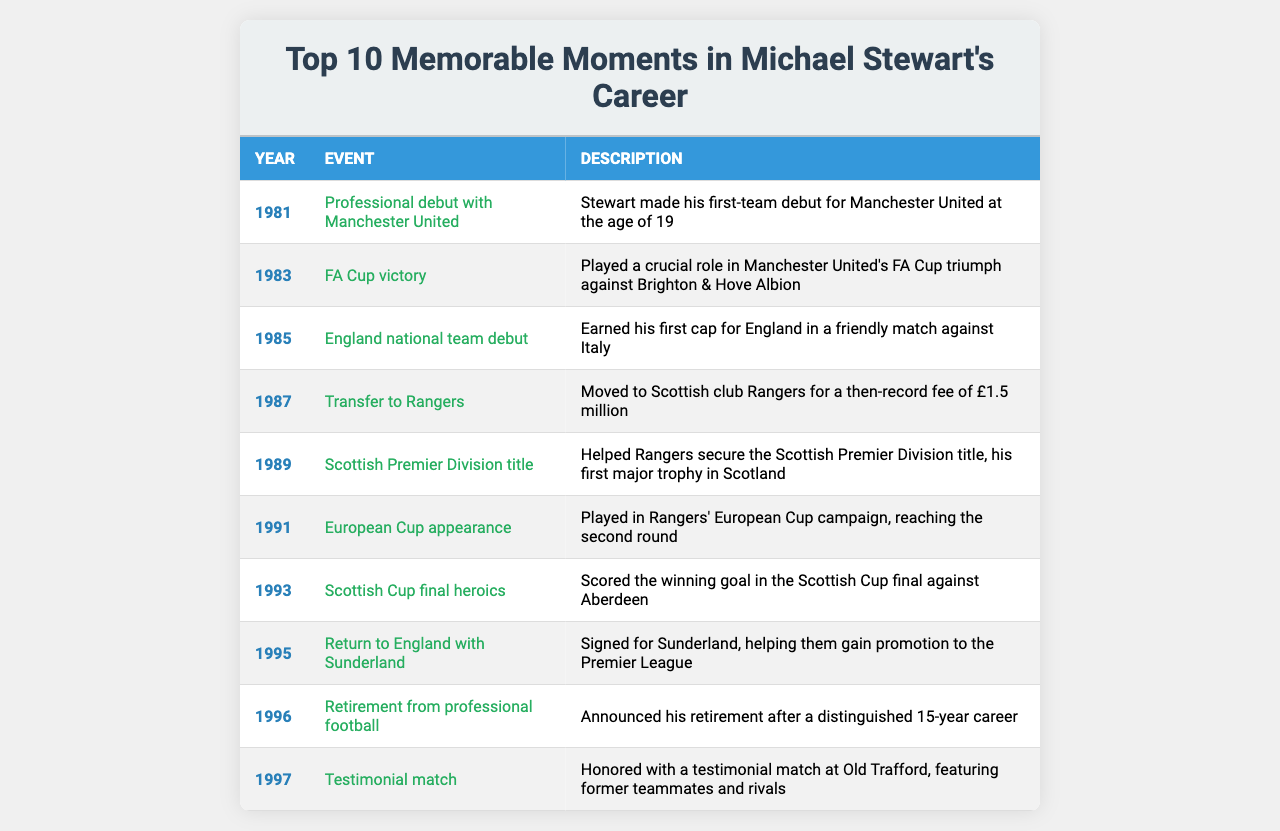What year did Michael Stewart make his professional debut? The table lists the memorable moments in Michael Stewart's career, and the first entry shows that he made his professional debut in the year 1981.
Answer: 1981 Which event marked Michael Stewart's first major trophy in Scotland? The table indicates that he helped Rangers secure the Scottish Premier Division title in 1989, which is noted as his first major trophy in Scotland.
Answer: Scottish Premier Division title Did Michael Stewart earn caps with the England national team? The table confirms that he made his England national team debut in 1985, which implies he earned caps.
Answer: Yes How many years was Michael Stewart's professional career? The table states that he retired in 1996 after a professional career beginning in 1981, which gives us 1996 - 1981 = 15 years.
Answer: 15 years What significant achievement occurred in the same year as Michael Stewart's transfer to Rangers? In 1987, the table notes Stewart's transfer to Rangers for a record fee, marking a significant achievement that year.
Answer: Transfer to Rangers Which event involved Michael Stewart scoring a winning goal? According to the table, the event of the Scottish Cup final in 1993 involved Stewart scoring the winning goal against Aberdeen.
Answer: Scottish Cup final In what year did Michael Stewart receive a testimonial match? The table shows that he was honored with a testimonial match in 1997, after his retirement in 1996.
Answer: 1997 List all major milestones related to Michael Stewart's career from 1983 to 1995. From the table, the milestones include: 1983 - FA Cup victory, 1985 - England national team debut, 1987 - Transfer to Rangers, 1989 - Scottish Premier Division title, 1991 - European Cup appearance, 1993 - Scottish Cup final heroics, and 1995 - Return to England with Sunderland.
Answer: Multiple milestones What did Michael Stewart achieve in the FA Cup in 1983? The table notes that in 1983, Stewart played a crucial role in Manchester United's FA Cup triumph against Brighton & Hove Albion.
Answer: FA Cup victory Was Michael Stewart's transfer fee to Rangers in 1987 considered record-breaking? The table explicitly states that Stewart moved to Rangers for a then-record fee of £1.5 million, confirming that it was record-breaking.
Answer: Yes What events in Michael Stewart's career occurred after his England national team debut? The events include: 1987 - Transfer to Rangers, 1989 - Scottish Premier Division title, 1991 - European Cup appearance, 1993 - Scottish Cup final heroics, 1995 - Return to England with Sunderland, and 1996 - Retirement.
Answer: Multiple events 